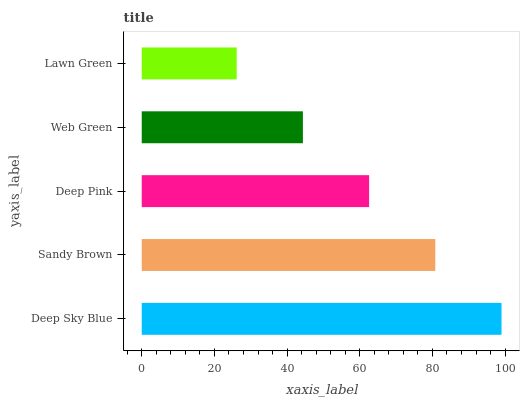Is Lawn Green the minimum?
Answer yes or no. Yes. Is Deep Sky Blue the maximum?
Answer yes or no. Yes. Is Sandy Brown the minimum?
Answer yes or no. No. Is Sandy Brown the maximum?
Answer yes or no. No. Is Deep Sky Blue greater than Sandy Brown?
Answer yes or no. Yes. Is Sandy Brown less than Deep Sky Blue?
Answer yes or no. Yes. Is Sandy Brown greater than Deep Sky Blue?
Answer yes or no. No. Is Deep Sky Blue less than Sandy Brown?
Answer yes or no. No. Is Deep Pink the high median?
Answer yes or no. Yes. Is Deep Pink the low median?
Answer yes or no. Yes. Is Deep Sky Blue the high median?
Answer yes or no. No. Is Sandy Brown the low median?
Answer yes or no. No. 